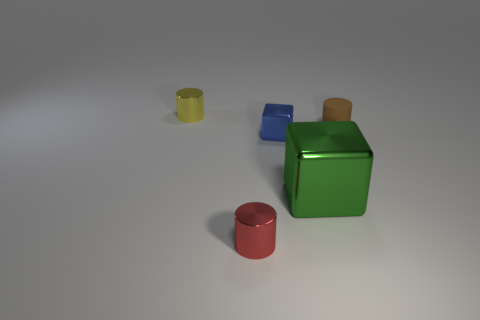Is the color of the large cube the same as the small rubber thing?
Ensure brevity in your answer.  No. Are there fewer yellow cylinders than big brown rubber cylinders?
Offer a terse response. No. What number of other large metal things have the same color as the large thing?
Make the answer very short. 0. There is a metallic cylinder behind the red metal thing; is its color the same as the large cube?
Provide a succinct answer. No. There is a yellow thing behind the small rubber cylinder; what shape is it?
Make the answer very short. Cylinder. There is a object that is behind the small brown matte cylinder; is there a cylinder in front of it?
Offer a terse response. Yes. What number of other green blocks have the same material as the green block?
Your response must be concise. 0. There is a metallic object that is left of the metallic cylinder to the right of the tiny shiny thing that is behind the blue cube; how big is it?
Provide a short and direct response. Small. What number of tiny brown things are in front of the big thing?
Make the answer very short. 0. Is the number of red objects greater than the number of blocks?
Keep it short and to the point. No. 